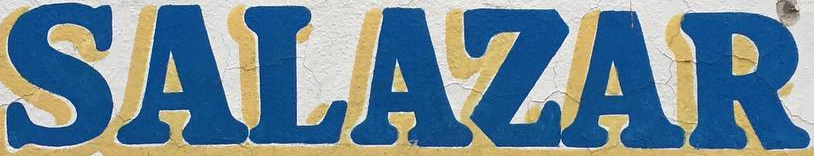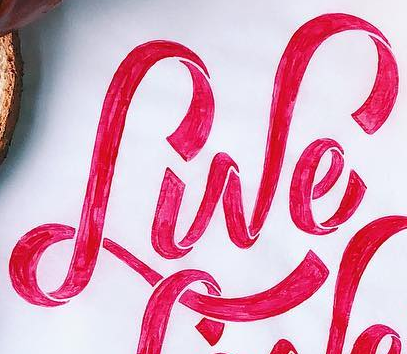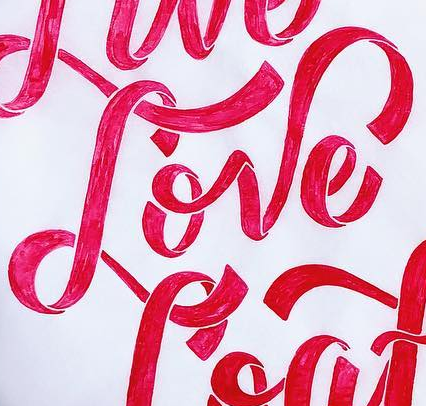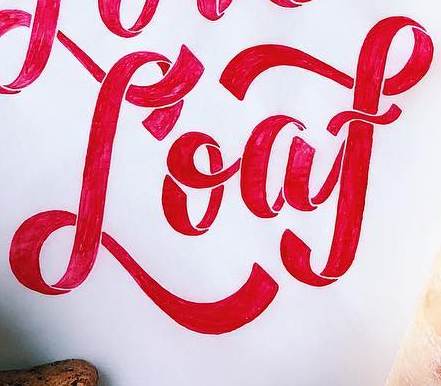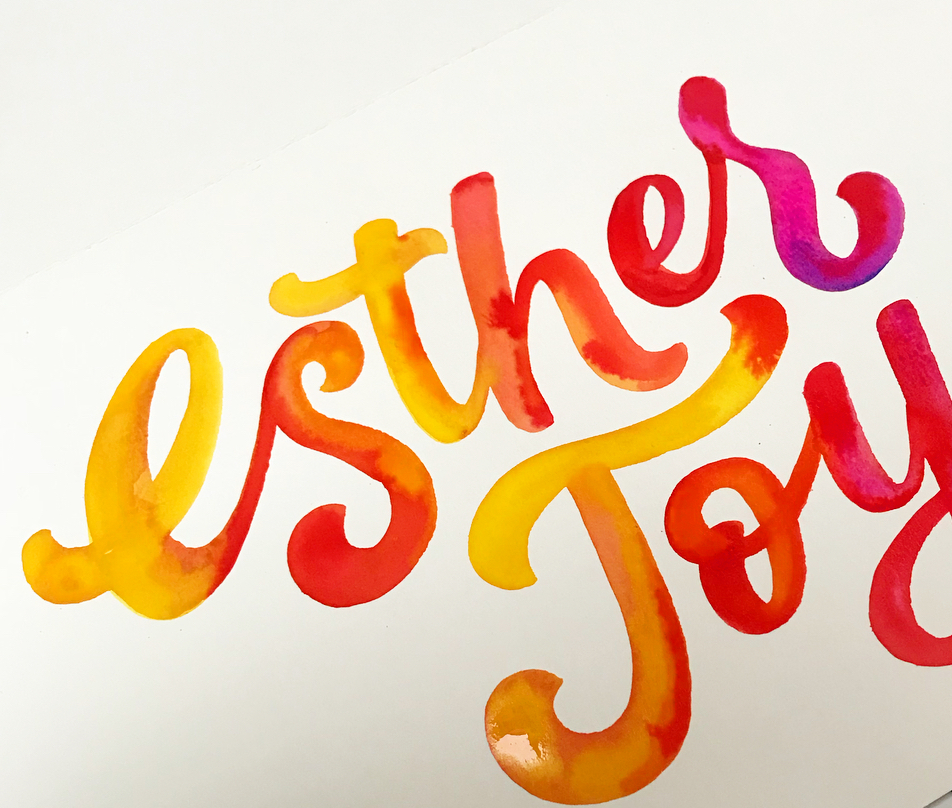Read the text content from these images in order, separated by a semicolon. SALAZAR; Lwe; Love; Loaf; Esthes 